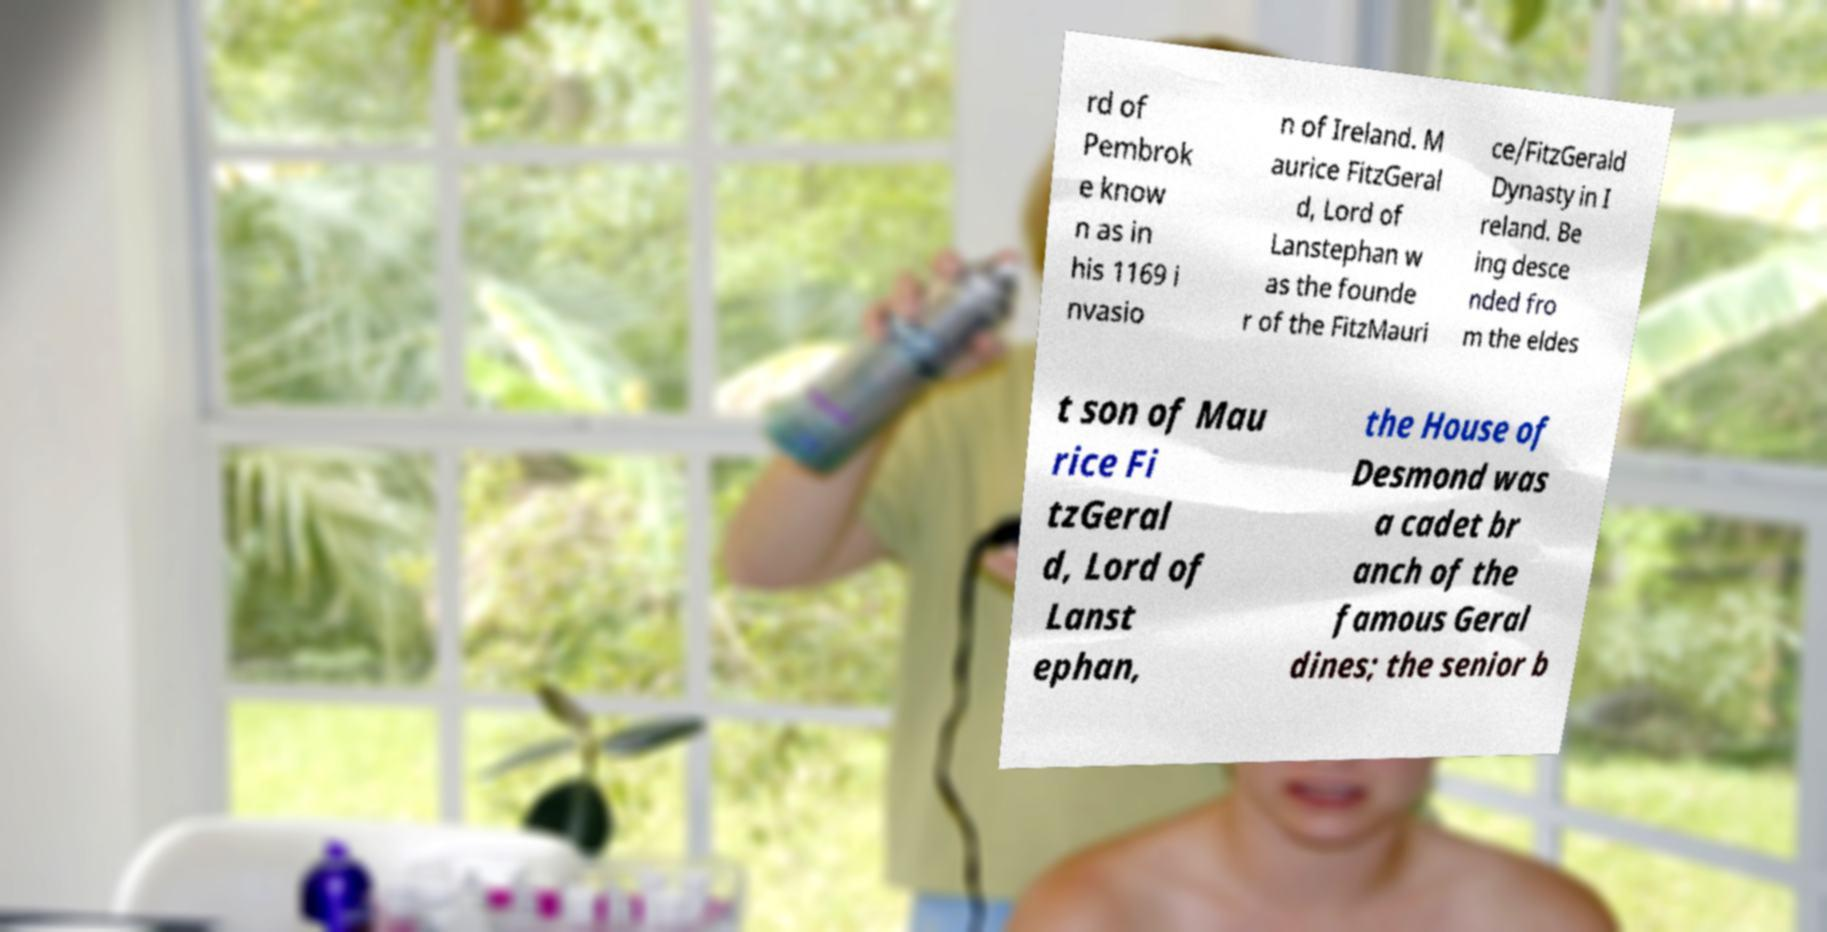For documentation purposes, I need the text within this image transcribed. Could you provide that? rd of Pembrok e know n as in his 1169 i nvasio n of Ireland. M aurice FitzGeral d, Lord of Lanstephan w as the founde r of the FitzMauri ce/FitzGerald Dynasty in I reland. Be ing desce nded fro m the eldes t son of Mau rice Fi tzGeral d, Lord of Lanst ephan, the House of Desmond was a cadet br anch of the famous Geral dines; the senior b 